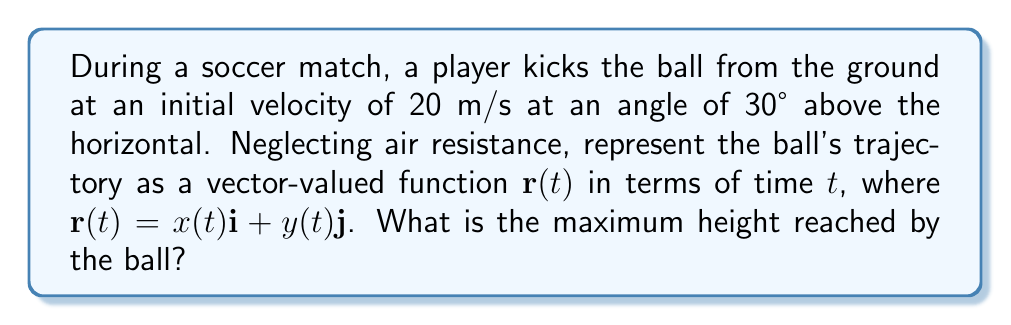Show me your answer to this math problem. Let's approach this step-by-step:

1) First, we need to decompose the initial velocity into its horizontal and vertical components:
   $v_x = v \cos \theta = 20 \cos 30° = 20 \cdot \frac{\sqrt{3}}{2} \approx 17.32$ m/s
   $v_y = v \sin \theta = 20 \sin 30° = 20 \cdot \frac{1}{2} = 10$ m/s

2) Now, we can write the equations for $x(t)$ and $y(t)$:
   $x(t) = v_x t = 17.32t$
   $y(t) = v_y t - \frac{1}{2}gt^2 = 10t - 4.9t^2$, where $g = 9.8$ m/s²

3) Therefore, the vector-valued function $\mathbf{r}(t)$ is:
   $$\mathbf{r}(t) = (17.32t)\mathbf{i} + (10t - 4.9t^2)\mathbf{j}$$

4) To find the maximum height, we need to find when the vertical velocity is zero:
   $\frac{dy}{dt} = 10 - 9.8t = 0$
   $t = \frac{10}{9.8} \approx 1.02$ seconds

5) Plugging this time back into the equation for $y(t)$:
   $y_{max} = 10(1.02) - 4.9(1.02)^2 \approx 5.1$ meters

Therefore, the maximum height reached by the ball is approximately 5.1 meters.
Answer: 5.1 meters 